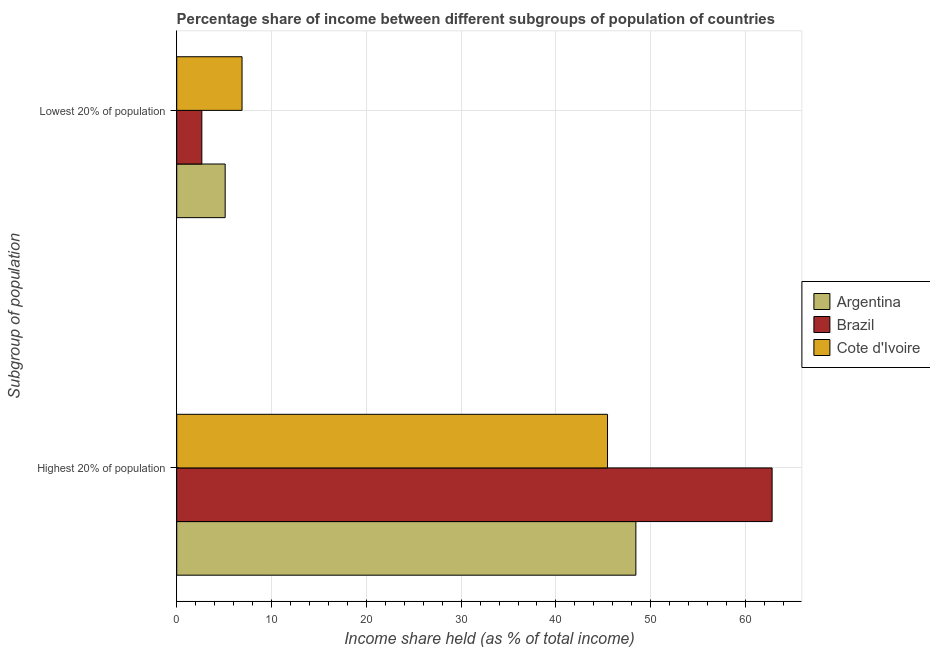How many different coloured bars are there?
Give a very brief answer. 3. What is the label of the 2nd group of bars from the top?
Your response must be concise. Highest 20% of population. What is the income share held by highest 20% of the population in Cote d'Ivoire?
Make the answer very short. 45.44. Across all countries, what is the maximum income share held by lowest 20% of the population?
Keep it short and to the point. 6.89. Across all countries, what is the minimum income share held by highest 20% of the population?
Your answer should be compact. 45.44. In which country was the income share held by highest 20% of the population maximum?
Keep it short and to the point. Brazil. In which country was the income share held by highest 20% of the population minimum?
Offer a very short reply. Cote d'Ivoire. What is the total income share held by highest 20% of the population in the graph?
Your answer should be very brief. 156.67. What is the difference between the income share held by lowest 20% of the population in Cote d'Ivoire and that in Argentina?
Provide a succinct answer. 1.78. What is the difference between the income share held by lowest 20% of the population in Argentina and the income share held by highest 20% of the population in Brazil?
Your answer should be compact. -57.69. What is the average income share held by lowest 20% of the population per country?
Your answer should be compact. 4.88. What is the difference between the income share held by lowest 20% of the population and income share held by highest 20% of the population in Cote d'Ivoire?
Give a very brief answer. -38.55. In how many countries, is the income share held by highest 20% of the population greater than 52 %?
Keep it short and to the point. 1. What is the ratio of the income share held by lowest 20% of the population in Cote d'Ivoire to that in Argentina?
Ensure brevity in your answer.  1.35. What does the 1st bar from the top in Highest 20% of population represents?
Make the answer very short. Cote d'Ivoire. Are the values on the major ticks of X-axis written in scientific E-notation?
Make the answer very short. No. Where does the legend appear in the graph?
Your answer should be compact. Center right. What is the title of the graph?
Keep it short and to the point. Percentage share of income between different subgroups of population of countries. Does "Turkey" appear as one of the legend labels in the graph?
Your answer should be very brief. No. What is the label or title of the X-axis?
Give a very brief answer. Income share held (as % of total income). What is the label or title of the Y-axis?
Provide a succinct answer. Subgroup of population. What is the Income share held (as % of total income) of Argentina in Highest 20% of population?
Your response must be concise. 48.43. What is the Income share held (as % of total income) of Brazil in Highest 20% of population?
Make the answer very short. 62.8. What is the Income share held (as % of total income) in Cote d'Ivoire in Highest 20% of population?
Ensure brevity in your answer.  45.44. What is the Income share held (as % of total income) of Argentina in Lowest 20% of population?
Your answer should be very brief. 5.11. What is the Income share held (as % of total income) in Brazil in Lowest 20% of population?
Ensure brevity in your answer.  2.65. What is the Income share held (as % of total income) of Cote d'Ivoire in Lowest 20% of population?
Offer a very short reply. 6.89. Across all Subgroup of population, what is the maximum Income share held (as % of total income) in Argentina?
Offer a terse response. 48.43. Across all Subgroup of population, what is the maximum Income share held (as % of total income) in Brazil?
Offer a very short reply. 62.8. Across all Subgroup of population, what is the maximum Income share held (as % of total income) of Cote d'Ivoire?
Provide a succinct answer. 45.44. Across all Subgroup of population, what is the minimum Income share held (as % of total income) in Argentina?
Your answer should be very brief. 5.11. Across all Subgroup of population, what is the minimum Income share held (as % of total income) of Brazil?
Give a very brief answer. 2.65. Across all Subgroup of population, what is the minimum Income share held (as % of total income) in Cote d'Ivoire?
Your answer should be very brief. 6.89. What is the total Income share held (as % of total income) of Argentina in the graph?
Provide a short and direct response. 53.54. What is the total Income share held (as % of total income) in Brazil in the graph?
Your answer should be very brief. 65.45. What is the total Income share held (as % of total income) of Cote d'Ivoire in the graph?
Make the answer very short. 52.33. What is the difference between the Income share held (as % of total income) in Argentina in Highest 20% of population and that in Lowest 20% of population?
Give a very brief answer. 43.32. What is the difference between the Income share held (as % of total income) of Brazil in Highest 20% of population and that in Lowest 20% of population?
Offer a terse response. 60.15. What is the difference between the Income share held (as % of total income) of Cote d'Ivoire in Highest 20% of population and that in Lowest 20% of population?
Make the answer very short. 38.55. What is the difference between the Income share held (as % of total income) of Argentina in Highest 20% of population and the Income share held (as % of total income) of Brazil in Lowest 20% of population?
Make the answer very short. 45.78. What is the difference between the Income share held (as % of total income) in Argentina in Highest 20% of population and the Income share held (as % of total income) in Cote d'Ivoire in Lowest 20% of population?
Offer a very short reply. 41.54. What is the difference between the Income share held (as % of total income) in Brazil in Highest 20% of population and the Income share held (as % of total income) in Cote d'Ivoire in Lowest 20% of population?
Ensure brevity in your answer.  55.91. What is the average Income share held (as % of total income) in Argentina per Subgroup of population?
Make the answer very short. 26.77. What is the average Income share held (as % of total income) of Brazil per Subgroup of population?
Make the answer very short. 32.73. What is the average Income share held (as % of total income) in Cote d'Ivoire per Subgroup of population?
Offer a terse response. 26.16. What is the difference between the Income share held (as % of total income) of Argentina and Income share held (as % of total income) of Brazil in Highest 20% of population?
Keep it short and to the point. -14.37. What is the difference between the Income share held (as % of total income) in Argentina and Income share held (as % of total income) in Cote d'Ivoire in Highest 20% of population?
Give a very brief answer. 2.99. What is the difference between the Income share held (as % of total income) of Brazil and Income share held (as % of total income) of Cote d'Ivoire in Highest 20% of population?
Ensure brevity in your answer.  17.36. What is the difference between the Income share held (as % of total income) of Argentina and Income share held (as % of total income) of Brazil in Lowest 20% of population?
Give a very brief answer. 2.46. What is the difference between the Income share held (as % of total income) in Argentina and Income share held (as % of total income) in Cote d'Ivoire in Lowest 20% of population?
Offer a terse response. -1.78. What is the difference between the Income share held (as % of total income) in Brazil and Income share held (as % of total income) in Cote d'Ivoire in Lowest 20% of population?
Your answer should be compact. -4.24. What is the ratio of the Income share held (as % of total income) in Argentina in Highest 20% of population to that in Lowest 20% of population?
Your answer should be very brief. 9.48. What is the ratio of the Income share held (as % of total income) in Brazil in Highest 20% of population to that in Lowest 20% of population?
Ensure brevity in your answer.  23.7. What is the ratio of the Income share held (as % of total income) in Cote d'Ivoire in Highest 20% of population to that in Lowest 20% of population?
Offer a terse response. 6.6. What is the difference between the highest and the second highest Income share held (as % of total income) of Argentina?
Your answer should be compact. 43.32. What is the difference between the highest and the second highest Income share held (as % of total income) in Brazil?
Offer a terse response. 60.15. What is the difference between the highest and the second highest Income share held (as % of total income) in Cote d'Ivoire?
Make the answer very short. 38.55. What is the difference between the highest and the lowest Income share held (as % of total income) of Argentina?
Provide a succinct answer. 43.32. What is the difference between the highest and the lowest Income share held (as % of total income) of Brazil?
Give a very brief answer. 60.15. What is the difference between the highest and the lowest Income share held (as % of total income) in Cote d'Ivoire?
Offer a terse response. 38.55. 